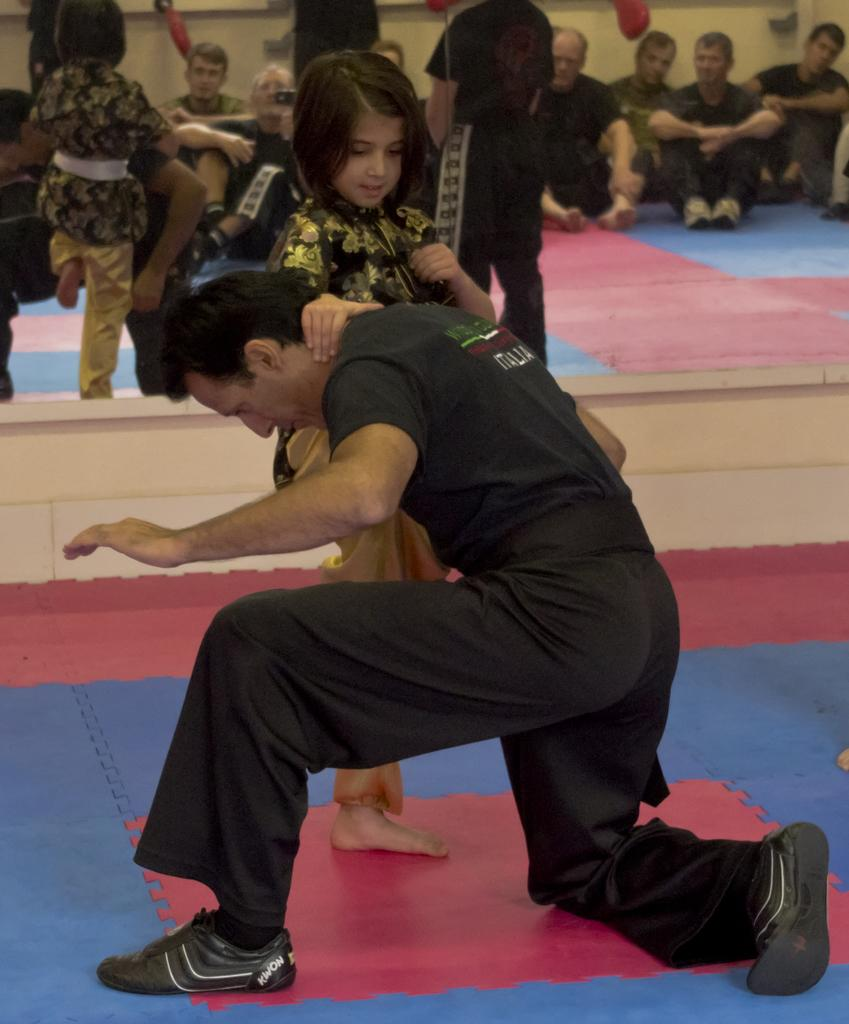What is the main action happening in the image? There is a person holding a girl in the image. Can you describe the positions of the people in the image? There are people sitting and standing in the image. What type of caption is written on the veil in the image? There is no veil or caption present in the image. Is there a stove visible in the image? There is no stove present in the image. 